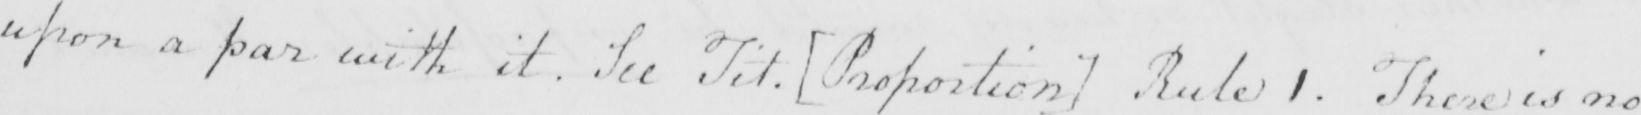Transcribe the text shown in this historical manuscript line. upon a par with it . See Tit .  [ Proportion ]  Rule 1 . There is no 